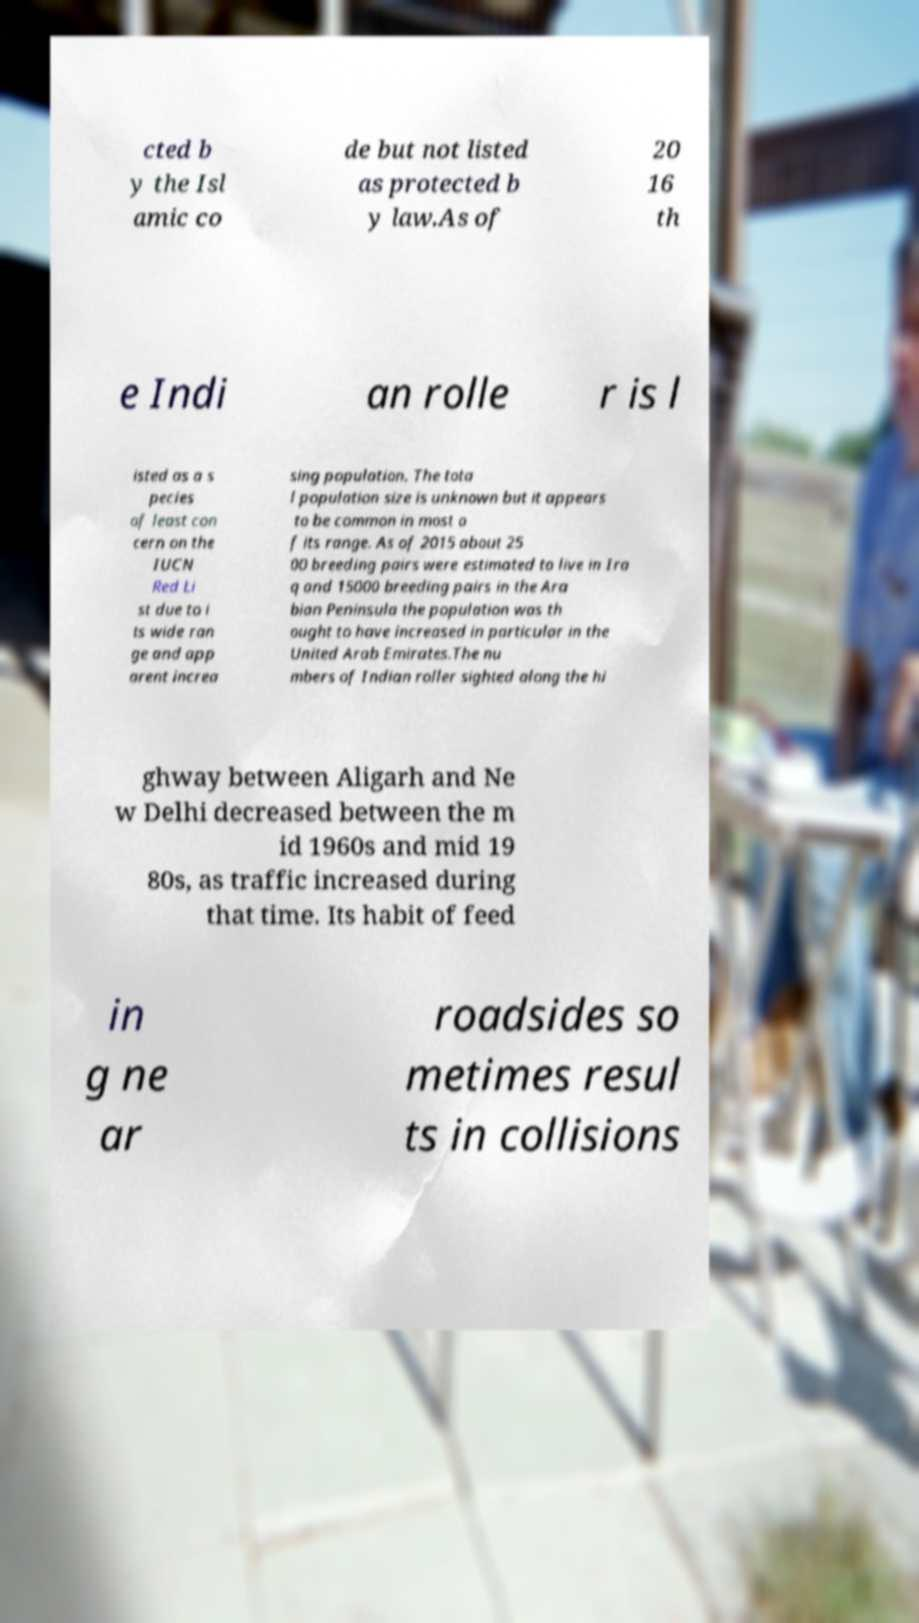Please identify and transcribe the text found in this image. cted b y the Isl amic co de but not listed as protected b y law.As of 20 16 th e Indi an rolle r is l isted as a s pecies of least con cern on the IUCN Red Li st due to i ts wide ran ge and app arent increa sing population. The tota l population size is unknown but it appears to be common in most o f its range. As of 2015 about 25 00 breeding pairs were estimated to live in Ira q and 15000 breeding pairs in the Ara bian Peninsula the population was th ought to have increased in particular in the United Arab Emirates.The nu mbers of Indian roller sighted along the hi ghway between Aligarh and Ne w Delhi decreased between the m id 1960s and mid 19 80s, as traffic increased during that time. Its habit of feed in g ne ar roadsides so metimes resul ts in collisions 